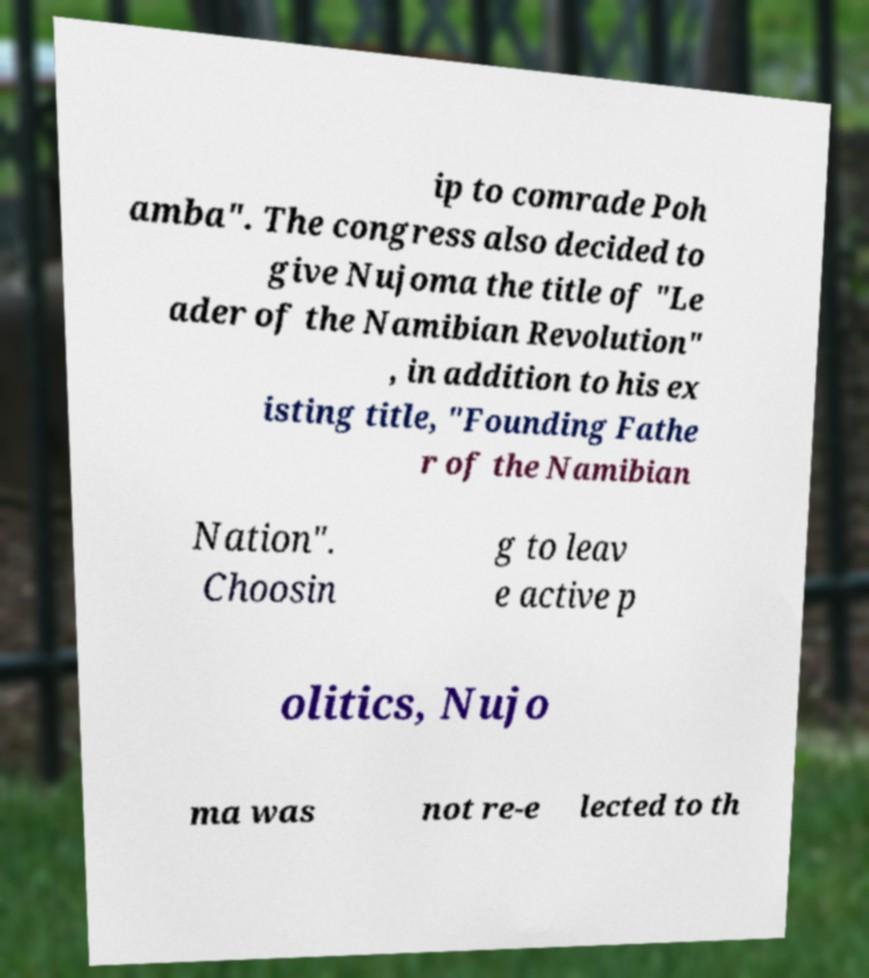Could you extract and type out the text from this image? ip to comrade Poh amba". The congress also decided to give Nujoma the title of "Le ader of the Namibian Revolution" , in addition to his ex isting title, "Founding Fathe r of the Namibian Nation". Choosin g to leav e active p olitics, Nujo ma was not re-e lected to th 